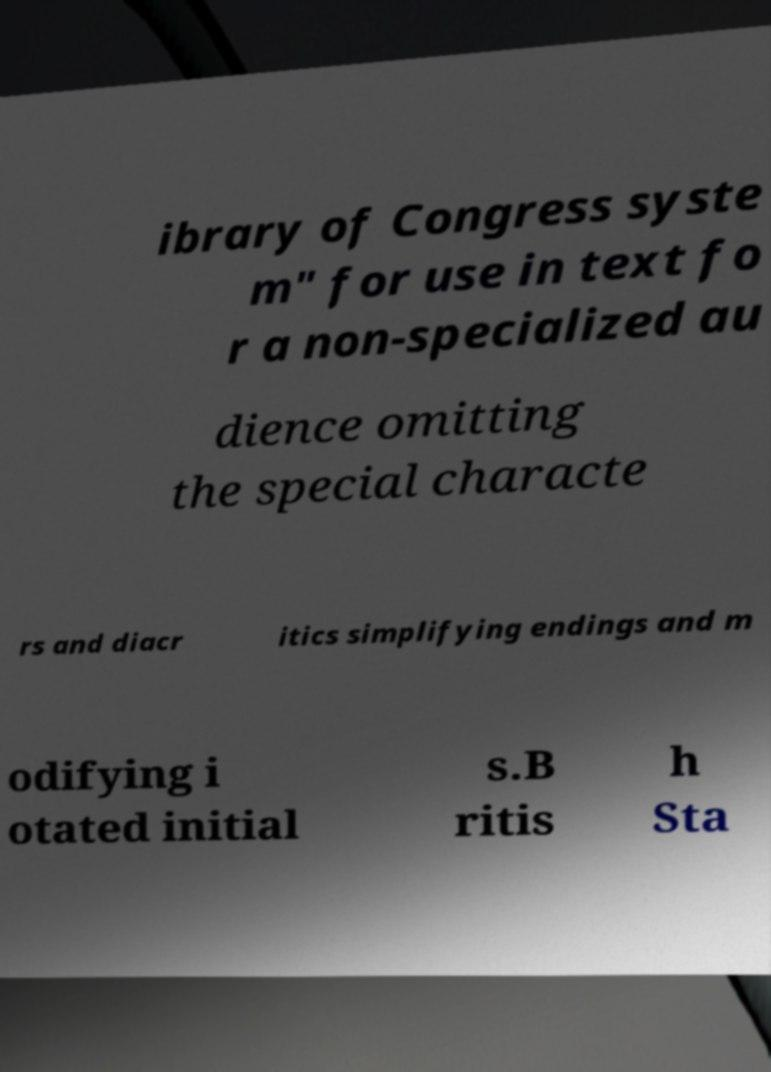There's text embedded in this image that I need extracted. Can you transcribe it verbatim? ibrary of Congress syste m" for use in text fo r a non-specialized au dience omitting the special characte rs and diacr itics simplifying endings and m odifying i otated initial s.B ritis h Sta 